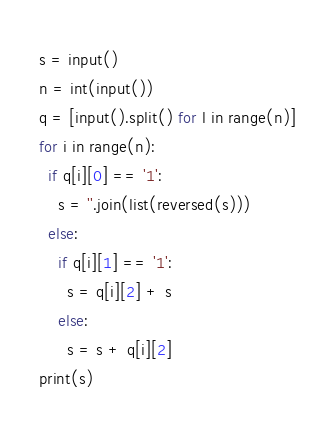<code> <loc_0><loc_0><loc_500><loc_500><_Python_>s = input()
n = int(input())
q = [input().split() for l in range(n)]
for i in range(n):
  if q[i][0] == '1':
    s = ''.join(list(reversed(s)))
  else:
    if q[i][1] == '1':
      s = q[i][2] + s
    else:
      s = s + q[i][2]
print(s)</code> 